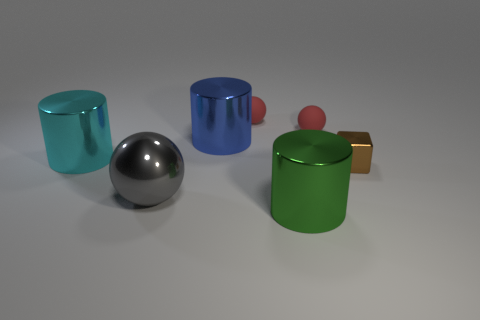Is there anything else that is the same size as the shiny sphere?
Your answer should be very brief. Yes. What number of large objects are right of the large ball and behind the gray ball?
Make the answer very short. 1. Is the number of blue things that are on the left side of the big gray thing greater than the number of small metal blocks in front of the brown metal object?
Provide a short and direct response. No. The cyan thing is what size?
Make the answer very short. Large. Are there any small brown metal objects of the same shape as the big blue shiny thing?
Ensure brevity in your answer.  No. Is the shape of the cyan thing the same as the big metallic object that is to the right of the large blue metal object?
Make the answer very short. Yes. There is a object that is both left of the green thing and in front of the tiny shiny cube; what is its size?
Ensure brevity in your answer.  Large. What number of small cubes are there?
Your answer should be very brief. 1. What material is the ball that is the same size as the cyan cylinder?
Offer a very short reply. Metal. Is there a red shiny object that has the same size as the gray sphere?
Offer a terse response. No. 